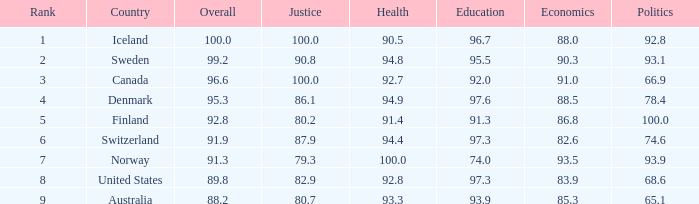When justice has a score of 80.7, what is the corresponding health score? 93.3. 